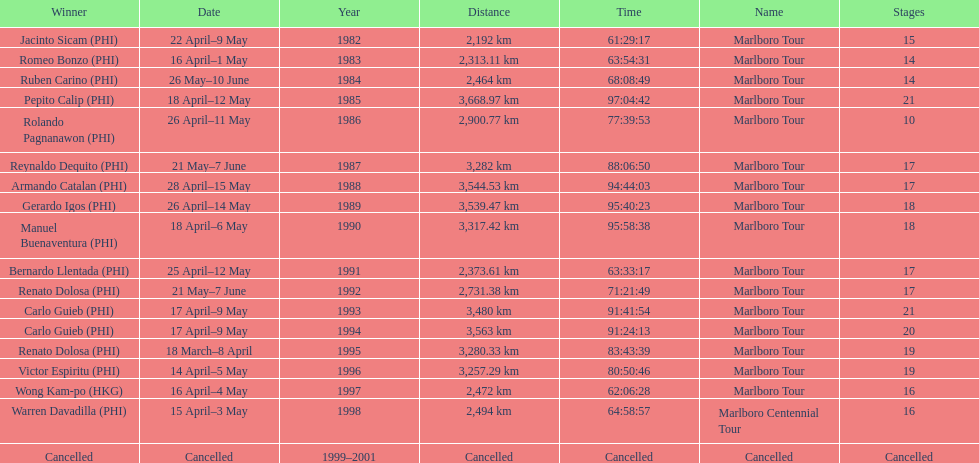Who achieved the most wins in marlboro tours? Carlo Guieb. 